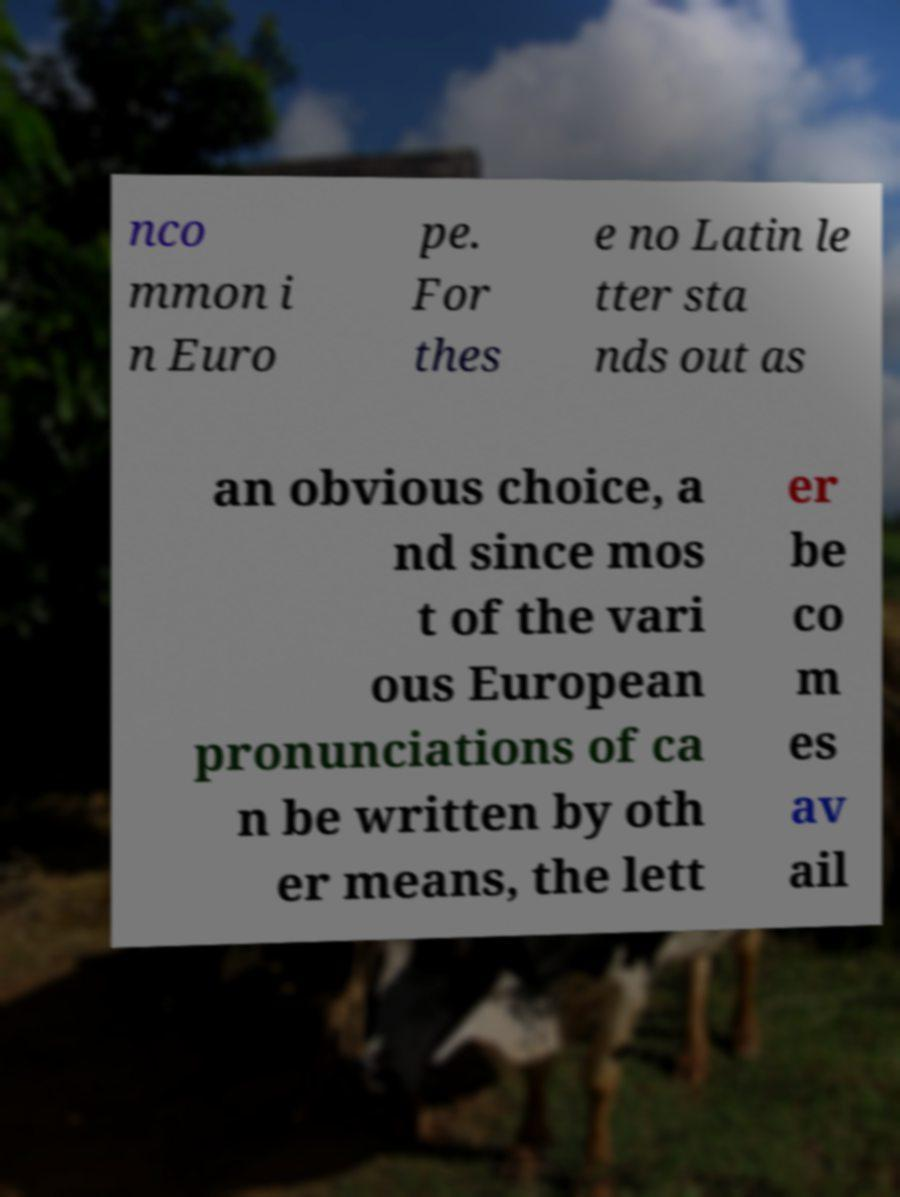For documentation purposes, I need the text within this image transcribed. Could you provide that? nco mmon i n Euro pe. For thes e no Latin le tter sta nds out as an obvious choice, a nd since mos t of the vari ous European pronunciations of ca n be written by oth er means, the lett er be co m es av ail 